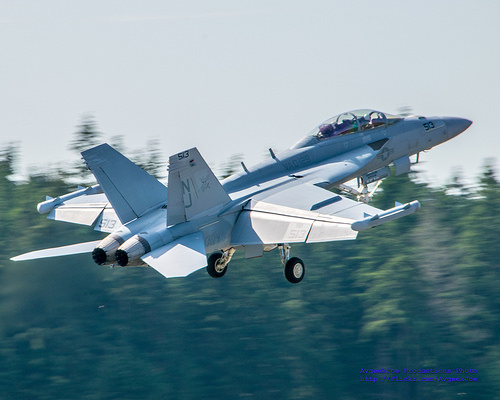<image>
Can you confirm if the jet is on the tree? No. The jet is not positioned on the tree. They may be near each other, but the jet is not supported by or resting on top of the tree. 